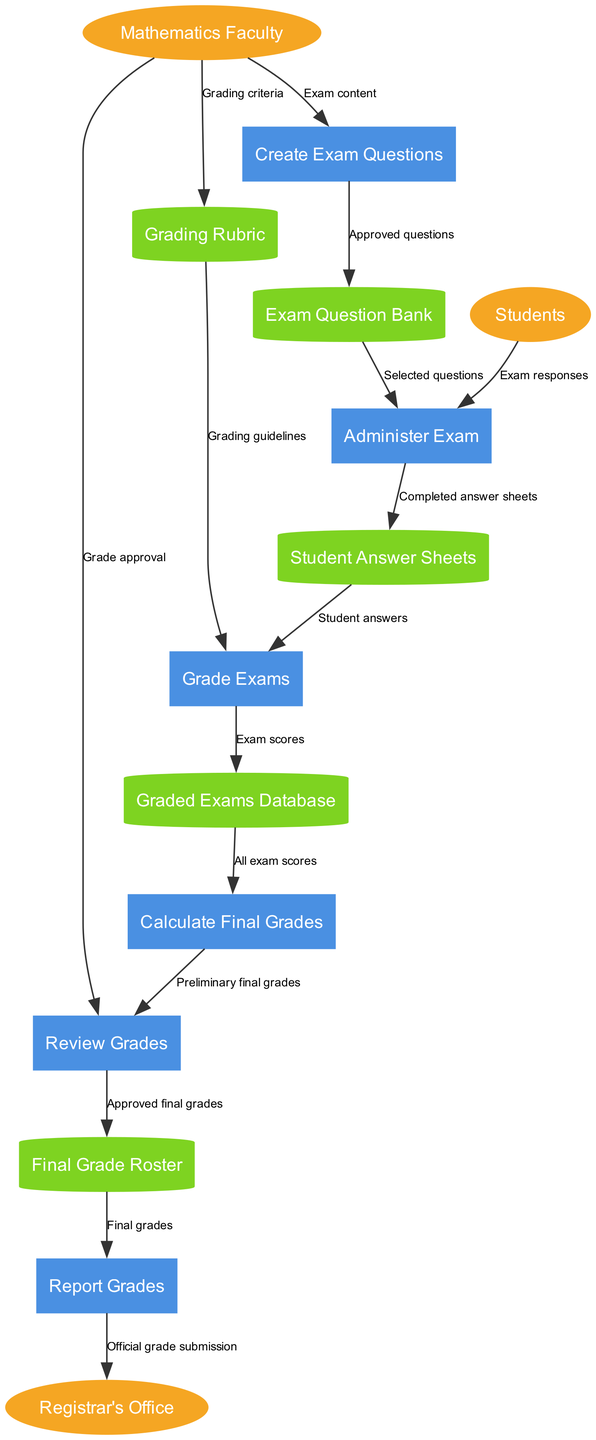What is the first process in the diagram? The diagram starts with the "Create Exam Questions" process, which is illustrated as the initial node connected to the external entity "Mathematics Faculty."
Answer: Create Exam Questions How many external entities are there in the diagram? The diagram lists three external entities: "Mathematics Faculty," "Students," and "Registrar's Office." Counting these gives a total of three entities.
Answer: 3 What data flows from "Grading Rubric" to "Grade Exams"? The label on the arrow connecting these two nodes reads "Grading guidelines," indicating this is the data flow between them.
Answer: Grading guidelines What is stored in the "Graded Exams Database"? The flow labeled "Exam scores" indicates that the results of grading exams are stored in this database.
Answer: Exam scores What is the final step that happens in the grading process? The distinct flow labeled "Official grade submission" shows that the last step involves reporting grades to the "Registrar's Office."
Answer: Official grade submission Which external entity receives the final grades? The "Registrar's Office" is the designated external entity that receives the final grades as required by the diagram.
Answer: Registrar's Office What connects "Calculate Final Grades" to "Review Grades"? The flow between these two processes is labeled "Preliminary final grades," denoting the information that passes from the grade calculation to the review stage.
Answer: Preliminary final grades What is the purpose of the "Review Grades" process? The "Review Grades" process serves to review and approve the grades before finalizing them, as indicated by the flow from "Mathematics Faculty" labeled "Grade approval."
Answer: Review and approval of grades 